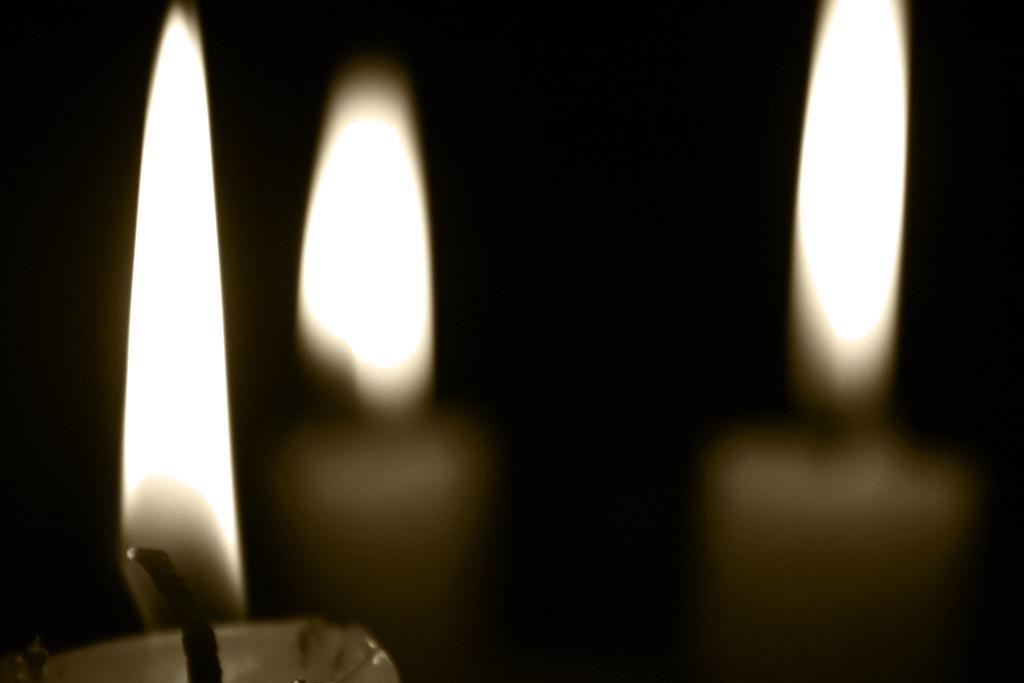What objects are present in the image? There are candles in the image. How many candles can be seen in the image? The number of candles is not specified, but there are at least one or more candles present. What might be the purpose of the candles in the image? The candles could be used for lighting, decoration, or a ritual. What type of arch can be seen in the image? There is no arch present in the image; it only features candles. 